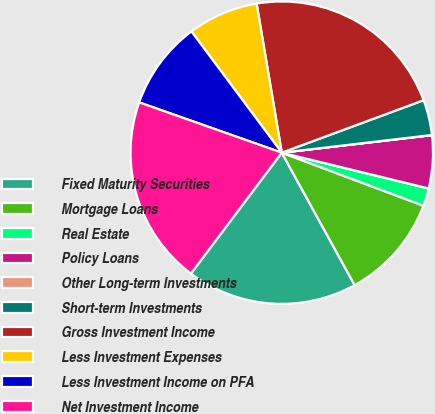<chart> <loc_0><loc_0><loc_500><loc_500><pie_chart><fcel>Fixed Maturity Securities<fcel>Mortgage Loans<fcel>Real Estate<fcel>Policy Loans<fcel>Other Long-term Investments<fcel>Short-term Investments<fcel>Gross Investment Income<fcel>Less Investment Expenses<fcel>Less Investment Income on PFA<fcel>Net Investment Income<nl><fcel>18.26%<fcel>11.29%<fcel>1.9%<fcel>5.65%<fcel>0.02%<fcel>3.77%<fcel>22.02%<fcel>7.53%<fcel>9.41%<fcel>20.14%<nl></chart> 